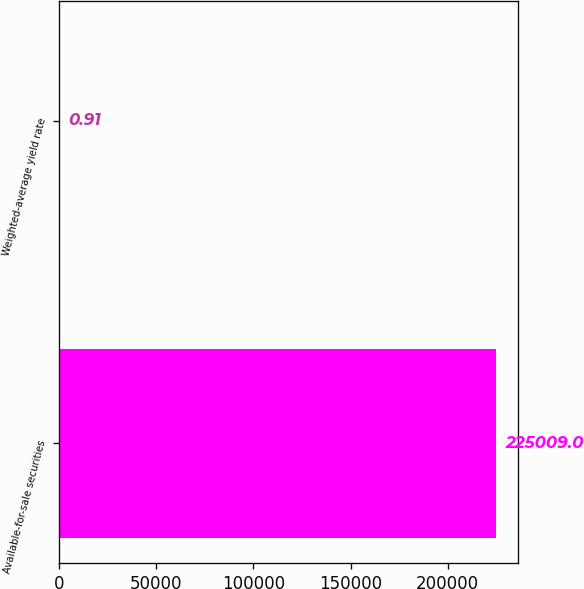Convert chart. <chart><loc_0><loc_0><loc_500><loc_500><bar_chart><fcel>Available-for-sale securities<fcel>Weighted-average yield rate<nl><fcel>225009<fcel>0.91<nl></chart> 